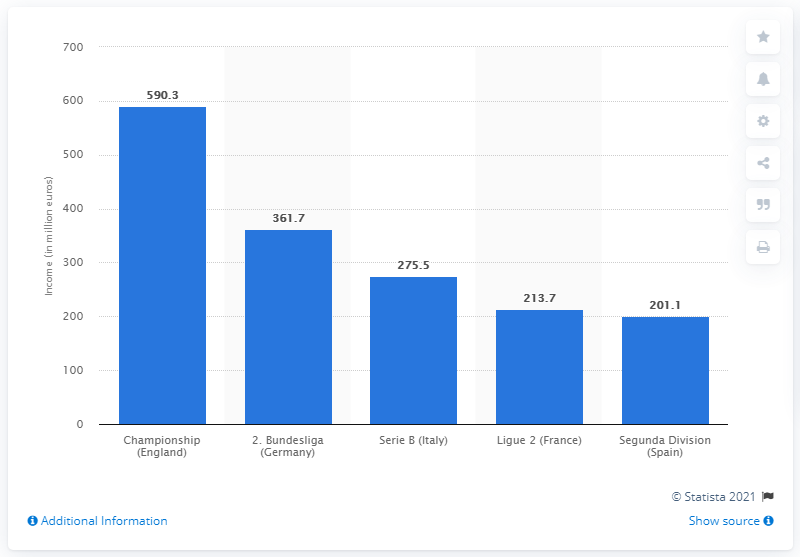Highlight a few significant elements in this photo. The total income of the second division of German professional soccer in the 2011/2012 season was 361.7 million euros. 